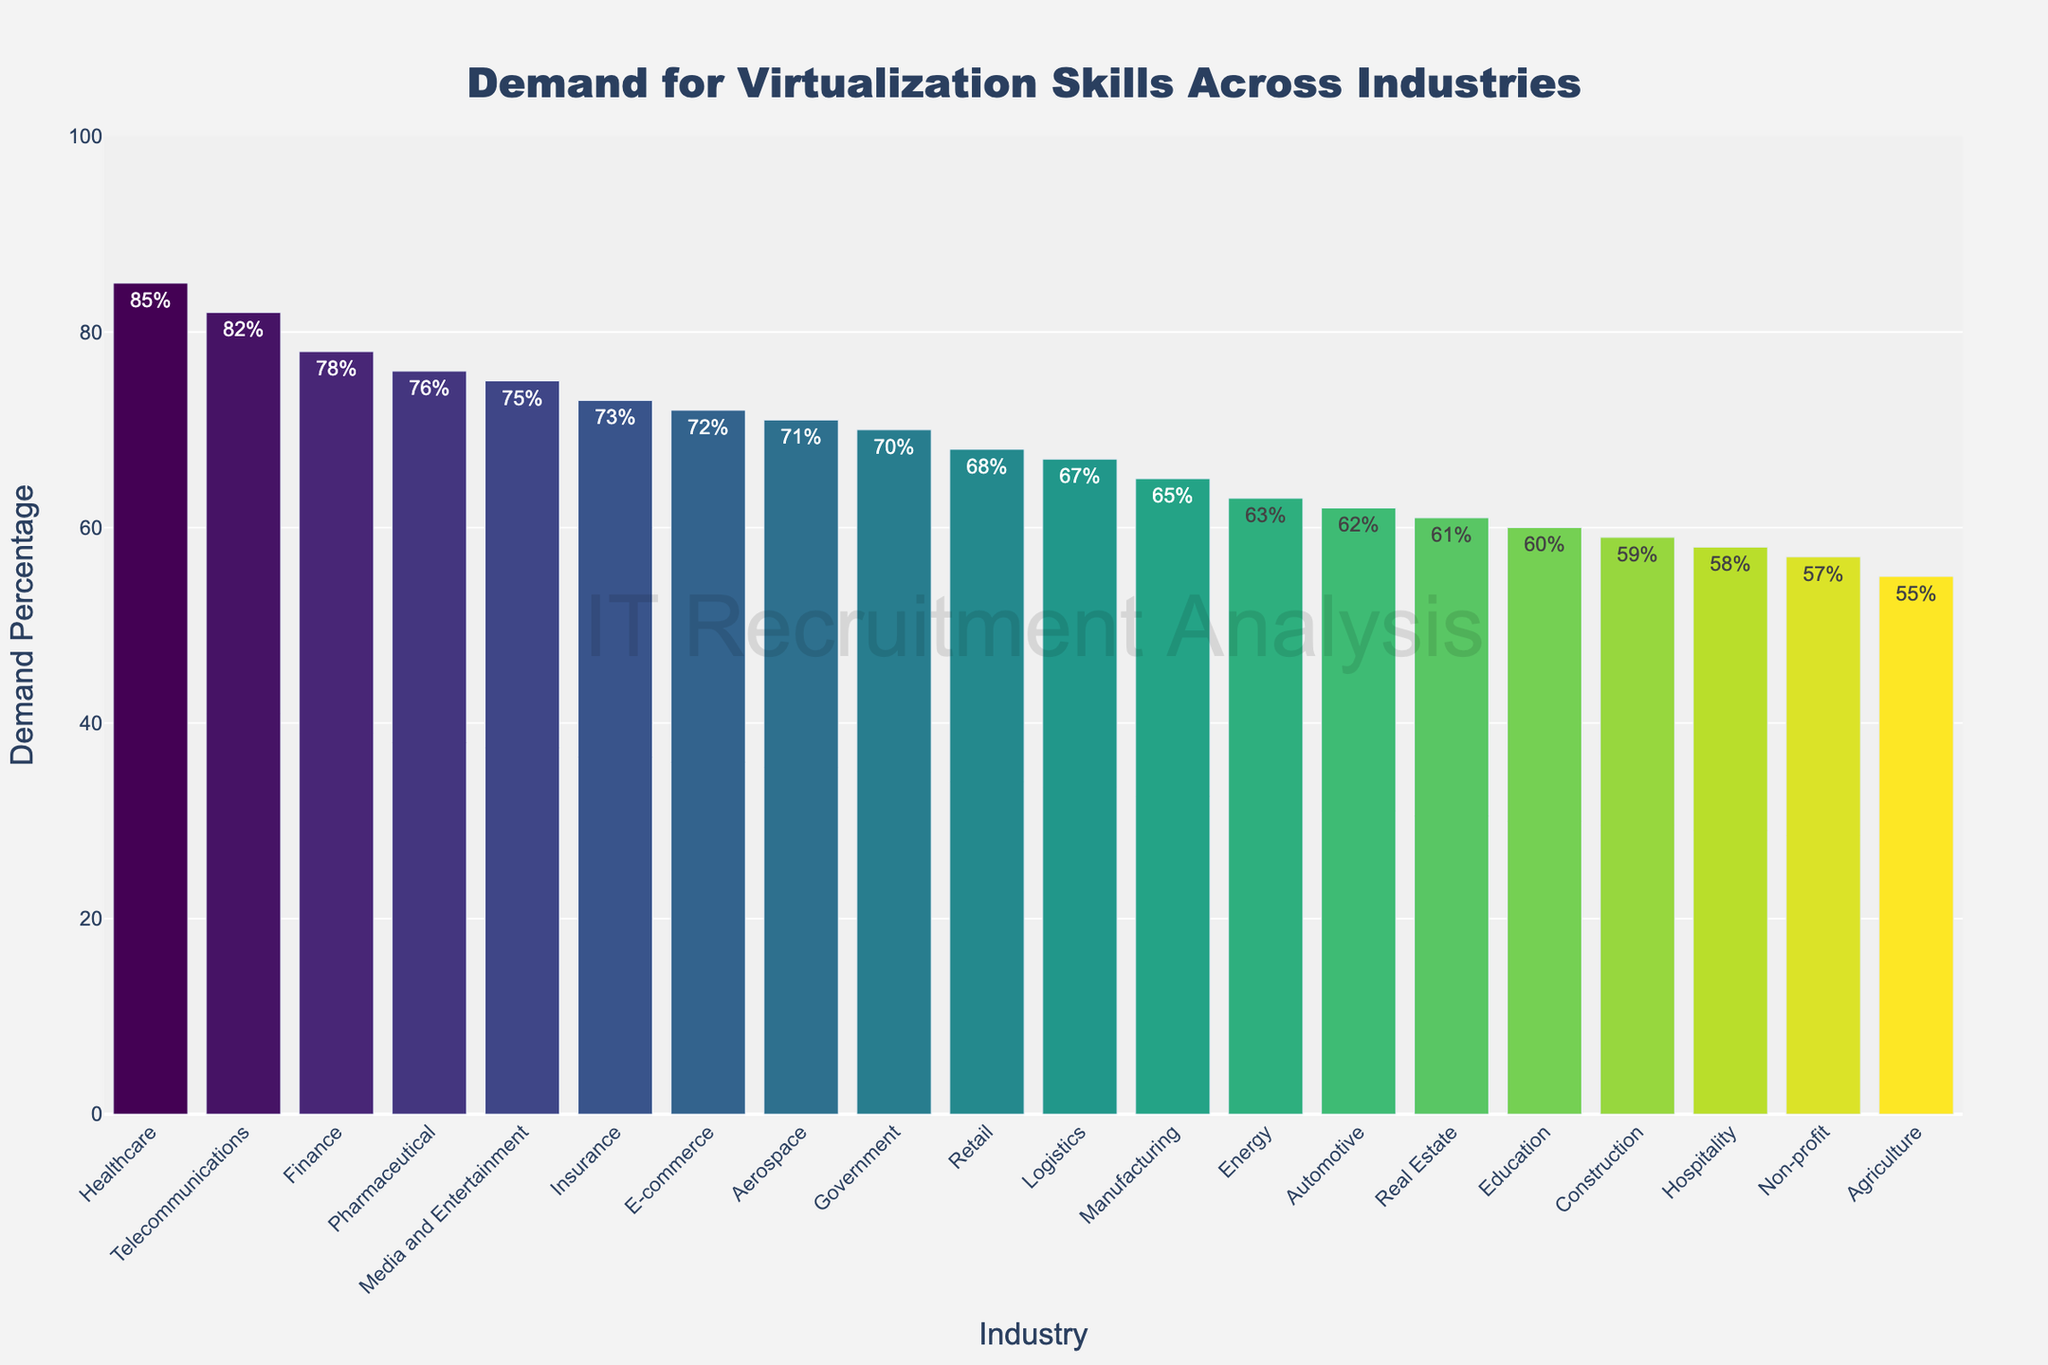Which industry shows the highest demand for virtualization skills? By examining the highest bar in the chart, we can see that the Healthcare industry has the highest demand, at 85%.
Answer: Healthcare Which industry has the lowest demand for virtualization skills? By identifying the shortest bar in the chart, Agriculture has the lowest demand at 55%.
Answer: Agriculture How much higher is the demand for virtualization skills in Healthcare compared to Agriculture? The demand in Healthcare is 85%, and in Agriculture, it is 55%. The difference between these values is calculated as 85% - 55% = 30%.
Answer: 30% Rank the top three industries with the highest demand for virtualization skills. By looking at the heights of the bars and comparing them, the top three industries are Healthcare (85%), Telecommunications (82%), and Finance (78%).
Answer: Healthcare, Telecommunications, Finance What is the average demand for virtualization skills across the Finance, Healthcare, and E-commerce industries? First, we add the demand percentages for the three industries: 78% (Finance) + 85% (Healthcare) + 72% (E-commerce) = 235%. Then, we divide by the number of industries (3) to get the average: 235% / 3 = 78.33%.
Answer: 78.33% Which industries have a demand percentage for virtualization skills that is less than 60%? By looking at the bars with heights less than 60%, we find the industries are Hospitality (58%), Agriculture (55%), and Non-profit (57%).
Answer: Hospitality, Agriculture, Non-profit Is the demand for virtualization skills in the E-commerce industry greater or less than in the Retail industry? By comparing the heights of the bars, E-commerce has a 72% demand, which is greater than Retail's 68% demand.
Answer: Greater What is the combined demand for virtualization skills across the Education, Automotive, and Construction industries? Adding the demand percentages of the three industries: Education (60%) + Automotive (62%) + Construction (59%) = 181%.
Answer: 181% How much lower is the demand in the Energy industry compared to the Finance industry? The demand in Energy is 63%, and in Finance, it is 78%. The difference is 78% - 63% = 15%.
Answer: 15% Which industry has a demand percentage closest to 70%? By examining the bar heights, the Government industry has a demand of 70%, which is exactly 70%.
Answer: Government 